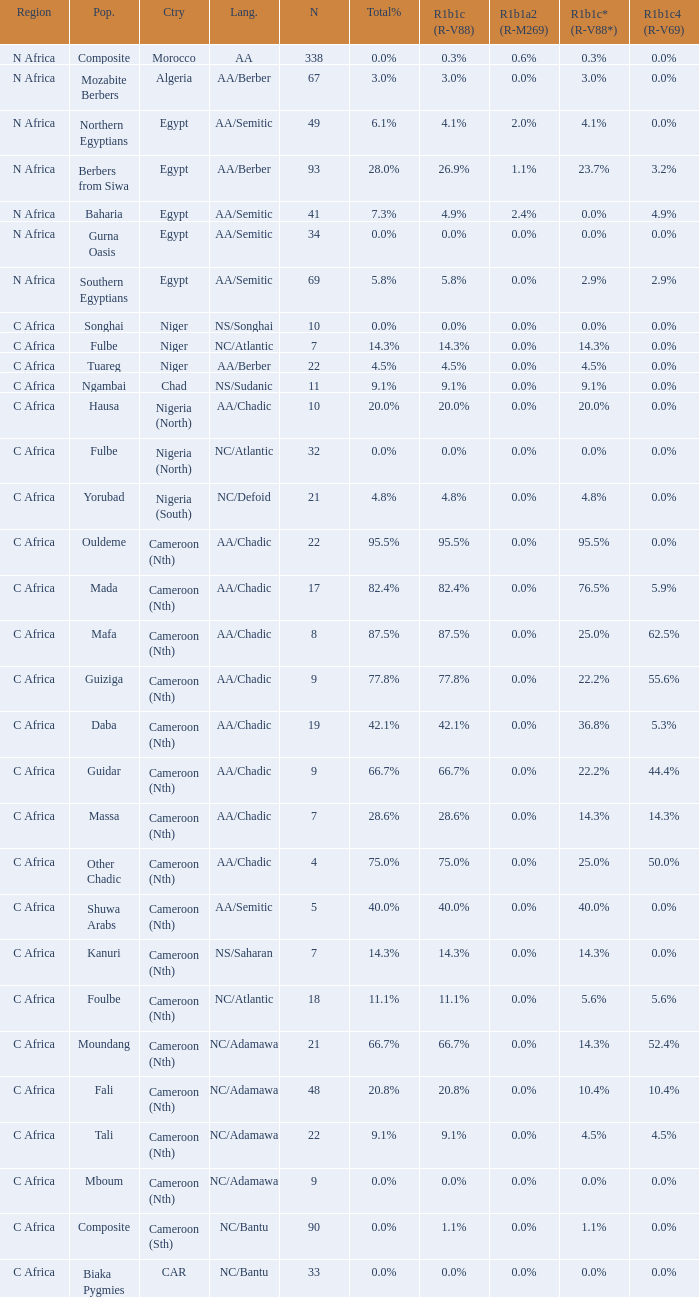What is the largest n value for 55.6% r1b1c4 (r-v69)? 9.0. 